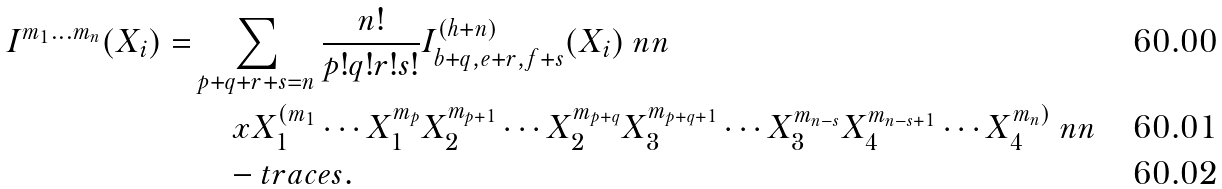Convert formula to latex. <formula><loc_0><loc_0><loc_500><loc_500>I ^ { m _ { 1 } \dots m _ { n } } ( X _ { i } ) = & \sum _ { p + q + r + s = n } \frac { n ! } { p ! q ! r ! s ! } I ^ { ( h + n ) } _ { b + q , e + r , f + s } ( X _ { i } ) \ n n \\ & \quad \ x X _ { 1 } ^ { ( m _ { 1 } } \cdots X _ { 1 } ^ { m _ { p } } X _ { 2 } ^ { m _ { p + 1 } } \cdots X _ { 2 } ^ { m _ { p + q } } X _ { 3 } ^ { m _ { p + q + 1 } } \cdots X _ { 3 } ^ { m _ { n - s } } X _ { 4 } ^ { m _ { n - s + 1 } } \cdots X _ { 4 } ^ { m _ { n } ) } \ n n \\ & \quad - t r a c e s .</formula> 